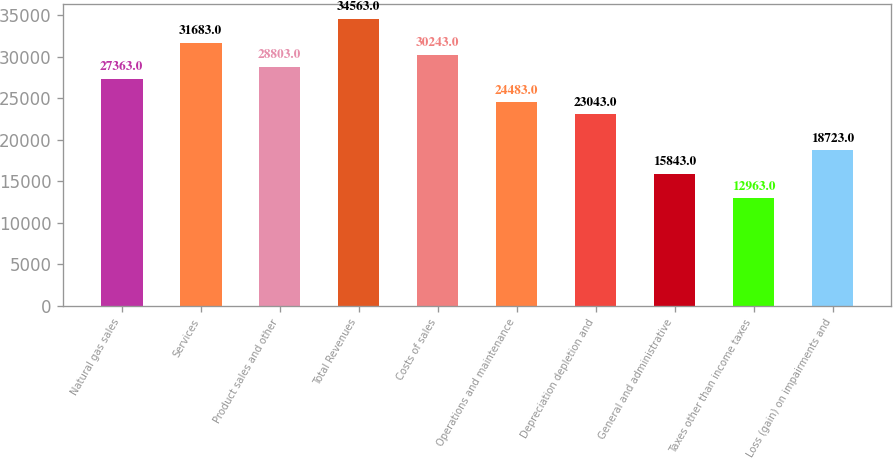Convert chart. <chart><loc_0><loc_0><loc_500><loc_500><bar_chart><fcel>Natural gas sales<fcel>Services<fcel>Product sales and other<fcel>Total Revenues<fcel>Costs of sales<fcel>Operations and maintenance<fcel>Depreciation depletion and<fcel>General and administrative<fcel>Taxes other than income taxes<fcel>Loss (gain) on impairments and<nl><fcel>27363<fcel>31683<fcel>28803<fcel>34563<fcel>30243<fcel>24483<fcel>23043<fcel>15843<fcel>12963<fcel>18723<nl></chart> 